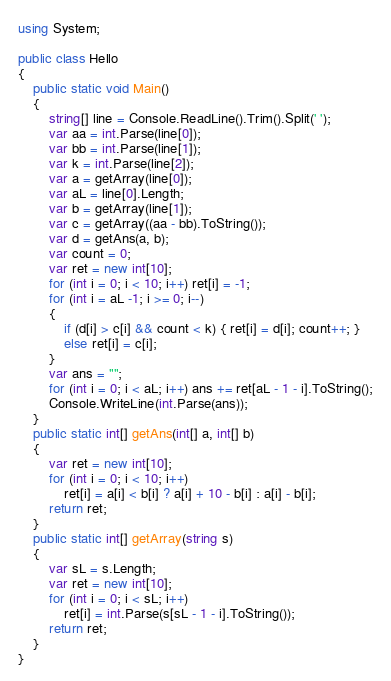Convert code to text. <code><loc_0><loc_0><loc_500><loc_500><_C#_>using System;

public class Hello
{
    public static void Main()
    {
        string[] line = Console.ReadLine().Trim().Split(' ');
        var aa = int.Parse(line[0]);
        var bb = int.Parse(line[1]);
        var k = int.Parse(line[2]);
        var a = getArray(line[0]);
        var aL = line[0].Length;
        var b = getArray(line[1]);
        var c = getArray((aa - bb).ToString());
        var d = getAns(a, b);
        var count = 0;
        var ret = new int[10];
        for (int i = 0; i < 10; i++) ret[i] = -1;
        for (int i = aL -1; i >= 0; i--)
        {
            if (d[i] > c[i] && count < k) { ret[i] = d[i]; count++; }
            else ret[i] = c[i];
        }
        var ans = "";
        for (int i = 0; i < aL; i++) ans += ret[aL - 1 - i].ToString();
        Console.WriteLine(int.Parse(ans));
    }
    public static int[] getAns(int[] a, int[] b)
    {
        var ret = new int[10];
        for (int i = 0; i < 10; i++)
            ret[i] = a[i] < b[i] ? a[i] + 10 - b[i] : a[i] - b[i];
        return ret;
    }
    public static int[] getArray(string s)
    {
        var sL = s.Length;
        var ret = new int[10];
        for (int i = 0; i < sL; i++)
            ret[i] = int.Parse(s[sL - 1 - i].ToString());
        return ret;
    }
}

</code> 